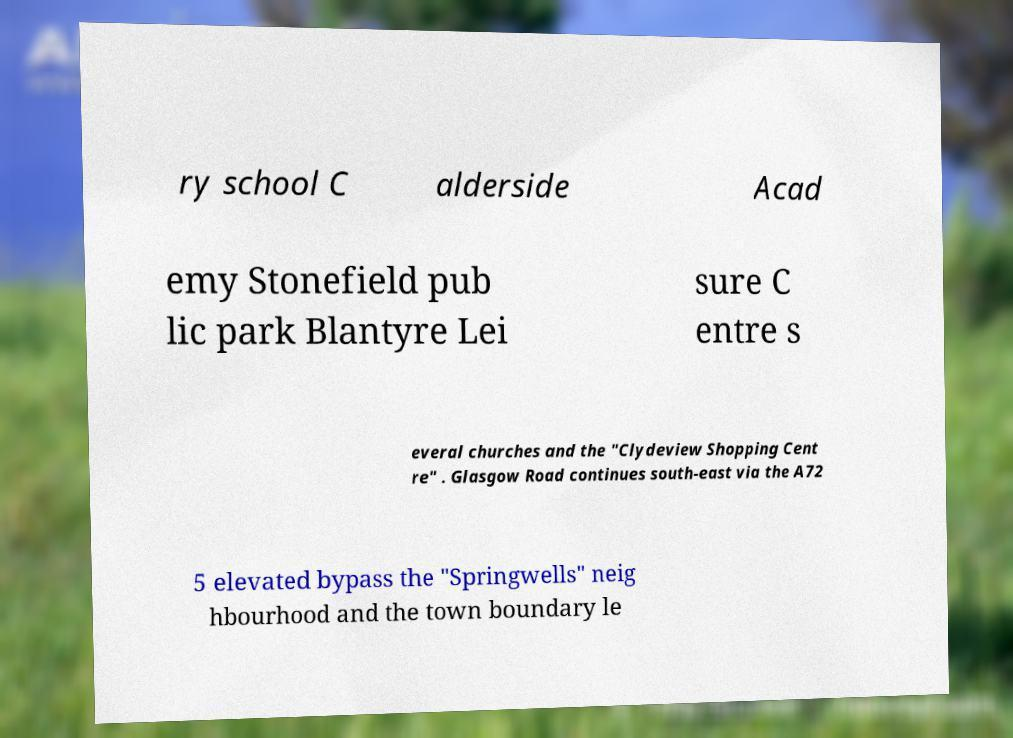Please identify and transcribe the text found in this image. ry school C alderside Acad emy Stonefield pub lic park Blantyre Lei sure C entre s everal churches and the "Clydeview Shopping Cent re" . Glasgow Road continues south-east via the A72 5 elevated bypass the "Springwells" neig hbourhood and the town boundary le 